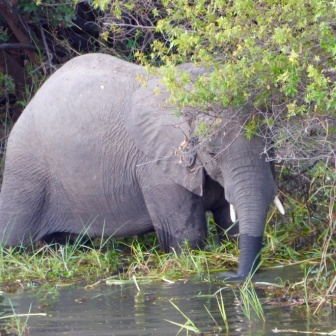If this scene were part of a fantasy world, what might happen next? In a fantastical twist, imagine the elephant suddenly lifting its trunk, and from beneath the water, a hidden kingdom of mythical creatures emerges. As the elephant steps aside, forest spirits, water nymphs, and magical fauna reveal themselves, coexisting in harmony. The scene might transform into a lively fairy reunion, with creatures dancing around, the trees whispering ancient secrets, and the water glowing with a mysterious, magical luminescence. The elephant, as the guardian of this enchanted realm, watches over the festivities, embodying a bridge between the ordinary world and this mystical wonderland. 